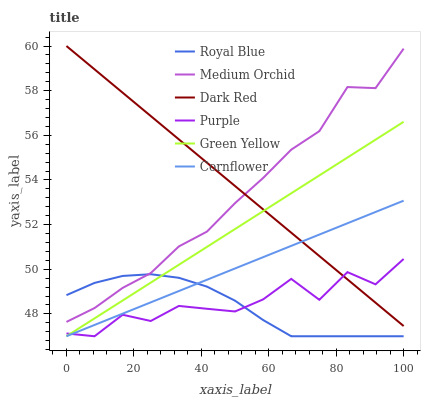Does Royal Blue have the minimum area under the curve?
Answer yes or no. Yes. Does Dark Red have the maximum area under the curve?
Answer yes or no. Yes. Does Purple have the minimum area under the curve?
Answer yes or no. No. Does Purple have the maximum area under the curve?
Answer yes or no. No. Is Cornflower the smoothest?
Answer yes or no. Yes. Is Purple the roughest?
Answer yes or no. Yes. Is Dark Red the smoothest?
Answer yes or no. No. Is Dark Red the roughest?
Answer yes or no. No. Does Cornflower have the lowest value?
Answer yes or no. Yes. Does Dark Red have the lowest value?
Answer yes or no. No. Does Dark Red have the highest value?
Answer yes or no. Yes. Does Purple have the highest value?
Answer yes or no. No. Is Green Yellow less than Medium Orchid?
Answer yes or no. Yes. Is Medium Orchid greater than Purple?
Answer yes or no. Yes. Does Purple intersect Cornflower?
Answer yes or no. Yes. Is Purple less than Cornflower?
Answer yes or no. No. Is Purple greater than Cornflower?
Answer yes or no. No. Does Green Yellow intersect Medium Orchid?
Answer yes or no. No. 